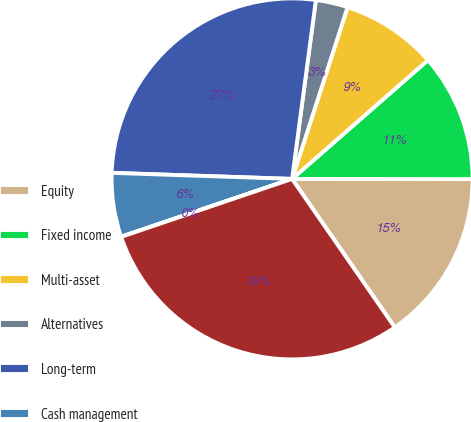Convert chart to OTSL. <chart><loc_0><loc_0><loc_500><loc_500><pie_chart><fcel>Equity<fcel>Fixed income<fcel>Multi-asset<fcel>Alternatives<fcel>Long-term<fcel>Cash management<fcel>Advisory<fcel>Total<nl><fcel>15.35%<fcel>11.45%<fcel>8.59%<fcel>2.87%<fcel>26.57%<fcel>5.73%<fcel>0.01%<fcel>29.43%<nl></chart> 